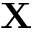Convert formula to latex. <formula><loc_0><loc_0><loc_500><loc_500>X</formula> 